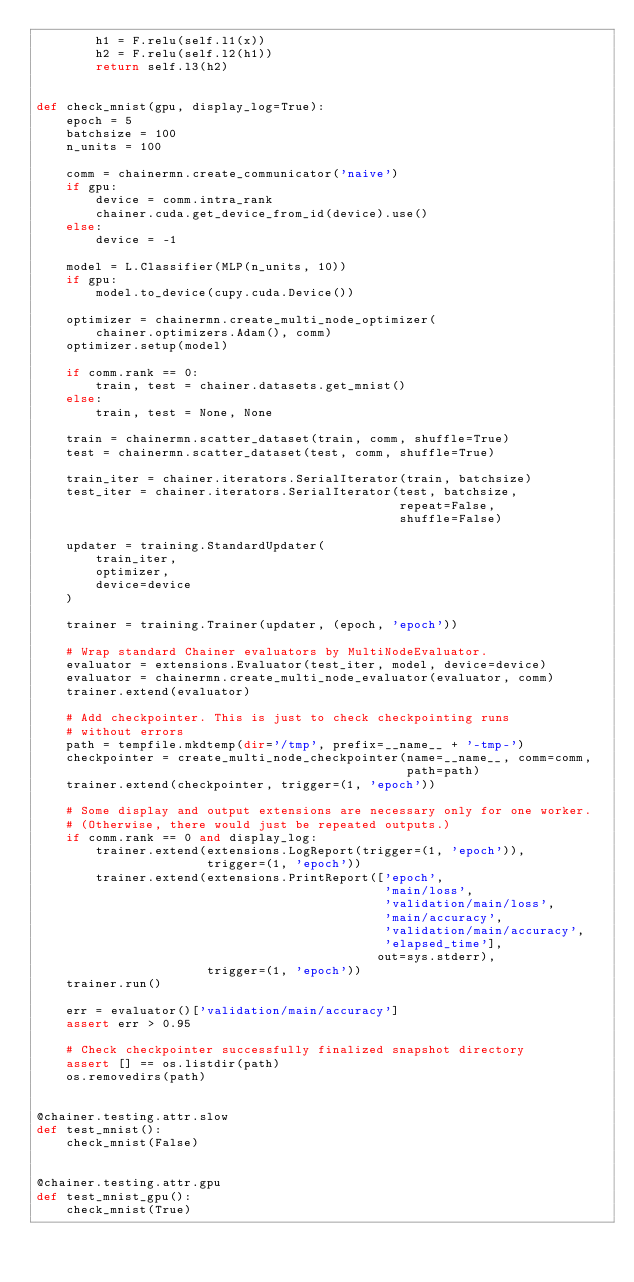Convert code to text. <code><loc_0><loc_0><loc_500><loc_500><_Python_>        h1 = F.relu(self.l1(x))
        h2 = F.relu(self.l2(h1))
        return self.l3(h2)


def check_mnist(gpu, display_log=True):
    epoch = 5
    batchsize = 100
    n_units = 100

    comm = chainermn.create_communicator('naive')
    if gpu:
        device = comm.intra_rank
        chainer.cuda.get_device_from_id(device).use()
    else:
        device = -1

    model = L.Classifier(MLP(n_units, 10))
    if gpu:
        model.to_device(cupy.cuda.Device())

    optimizer = chainermn.create_multi_node_optimizer(
        chainer.optimizers.Adam(), comm)
    optimizer.setup(model)

    if comm.rank == 0:
        train, test = chainer.datasets.get_mnist()
    else:
        train, test = None, None

    train = chainermn.scatter_dataset(train, comm, shuffle=True)
    test = chainermn.scatter_dataset(test, comm, shuffle=True)

    train_iter = chainer.iterators.SerialIterator(train, batchsize)
    test_iter = chainer.iterators.SerialIterator(test, batchsize,
                                                 repeat=False,
                                                 shuffle=False)

    updater = training.StandardUpdater(
        train_iter,
        optimizer,
        device=device
    )

    trainer = training.Trainer(updater, (epoch, 'epoch'))

    # Wrap standard Chainer evaluators by MultiNodeEvaluator.
    evaluator = extensions.Evaluator(test_iter, model, device=device)
    evaluator = chainermn.create_multi_node_evaluator(evaluator, comm)
    trainer.extend(evaluator)

    # Add checkpointer. This is just to check checkpointing runs
    # without errors
    path = tempfile.mkdtemp(dir='/tmp', prefix=__name__ + '-tmp-')
    checkpointer = create_multi_node_checkpointer(name=__name__, comm=comm,
                                                  path=path)
    trainer.extend(checkpointer, trigger=(1, 'epoch'))

    # Some display and output extensions are necessary only for one worker.
    # (Otherwise, there would just be repeated outputs.)
    if comm.rank == 0 and display_log:
        trainer.extend(extensions.LogReport(trigger=(1, 'epoch')),
                       trigger=(1, 'epoch'))
        trainer.extend(extensions.PrintReport(['epoch',
                                               'main/loss',
                                               'validation/main/loss',
                                               'main/accuracy',
                                               'validation/main/accuracy',
                                               'elapsed_time'],
                                              out=sys.stderr),
                       trigger=(1, 'epoch'))
    trainer.run()

    err = evaluator()['validation/main/accuracy']
    assert err > 0.95

    # Check checkpointer successfully finalized snapshot directory
    assert [] == os.listdir(path)
    os.removedirs(path)


@chainer.testing.attr.slow
def test_mnist():
    check_mnist(False)


@chainer.testing.attr.gpu
def test_mnist_gpu():
    check_mnist(True)

</code> 